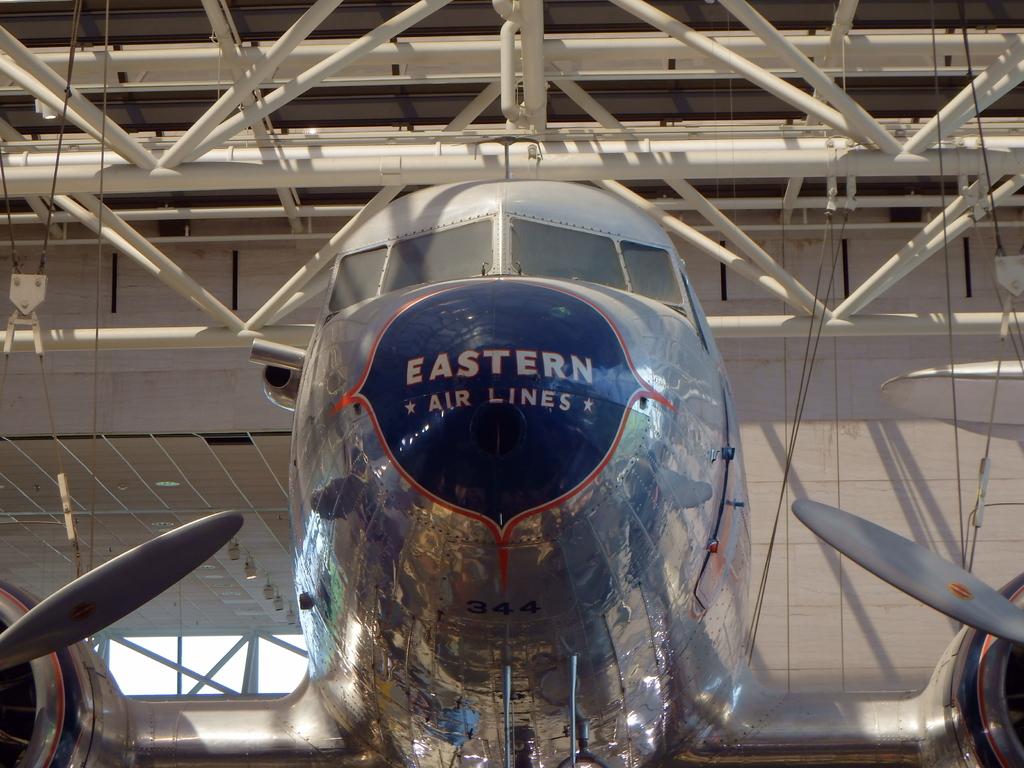What airline does this aircraft belong to?
Make the answer very short. Eastern. What kind of numbers are shown?
Provide a succinct answer. 344. 